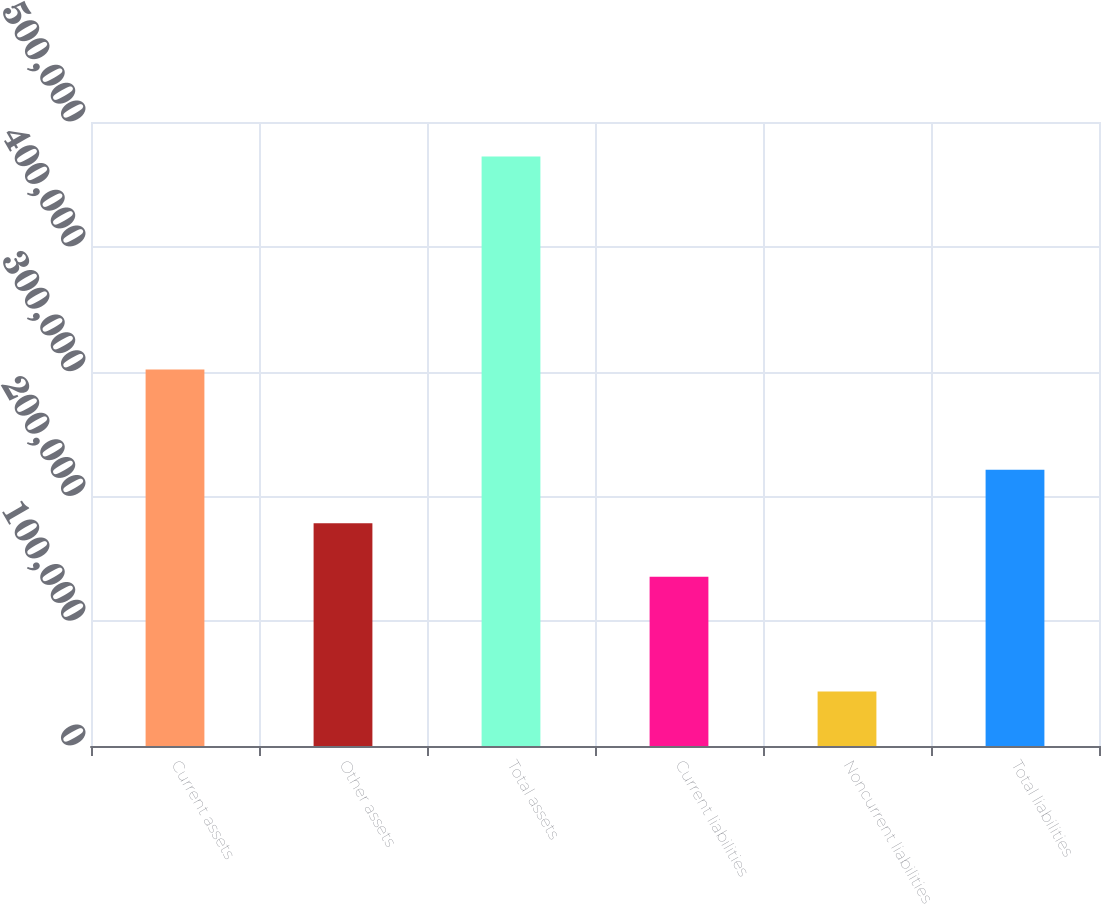Convert chart to OTSL. <chart><loc_0><loc_0><loc_500><loc_500><bar_chart><fcel>Current assets<fcel>Other assets<fcel>Total assets<fcel>Current liabilities<fcel>Noncurrent liabilities<fcel>Total liabilities<nl><fcel>301769<fcel>178502<fcel>472391<fcel>135622<fcel>43591<fcel>221382<nl></chart> 